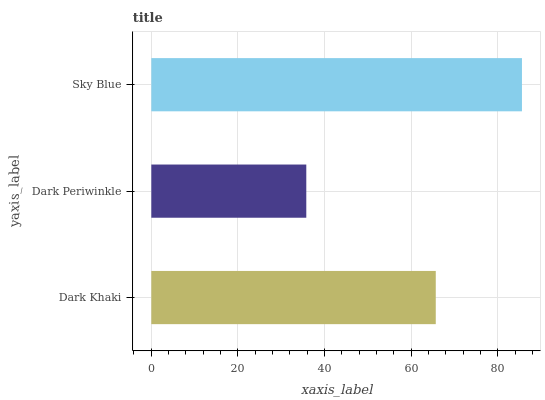Is Dark Periwinkle the minimum?
Answer yes or no. Yes. Is Sky Blue the maximum?
Answer yes or no. Yes. Is Sky Blue the minimum?
Answer yes or no. No. Is Dark Periwinkle the maximum?
Answer yes or no. No. Is Sky Blue greater than Dark Periwinkle?
Answer yes or no. Yes. Is Dark Periwinkle less than Sky Blue?
Answer yes or no. Yes. Is Dark Periwinkle greater than Sky Blue?
Answer yes or no. No. Is Sky Blue less than Dark Periwinkle?
Answer yes or no. No. Is Dark Khaki the high median?
Answer yes or no. Yes. Is Dark Khaki the low median?
Answer yes or no. Yes. Is Dark Periwinkle the high median?
Answer yes or no. No. Is Sky Blue the low median?
Answer yes or no. No. 